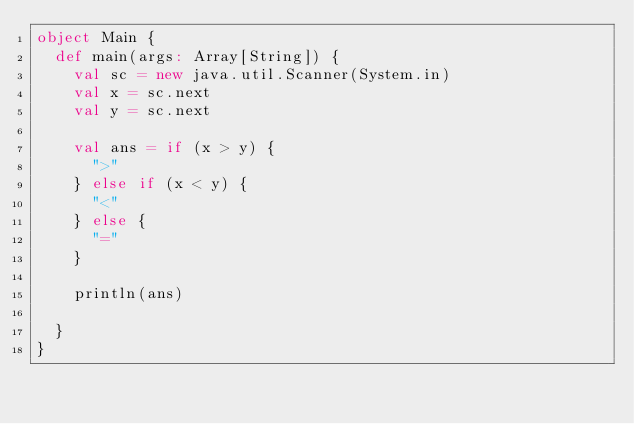<code> <loc_0><loc_0><loc_500><loc_500><_Scala_>object Main {
  def main(args: Array[String]) {
    val sc = new java.util.Scanner(System.in)
    val x = sc.next
    val y = sc.next

    val ans = if (x > y) {
      ">"
    } else if (x < y) {
      "<"
    } else {
      "="
    }

    println(ans)

  }
}
</code> 